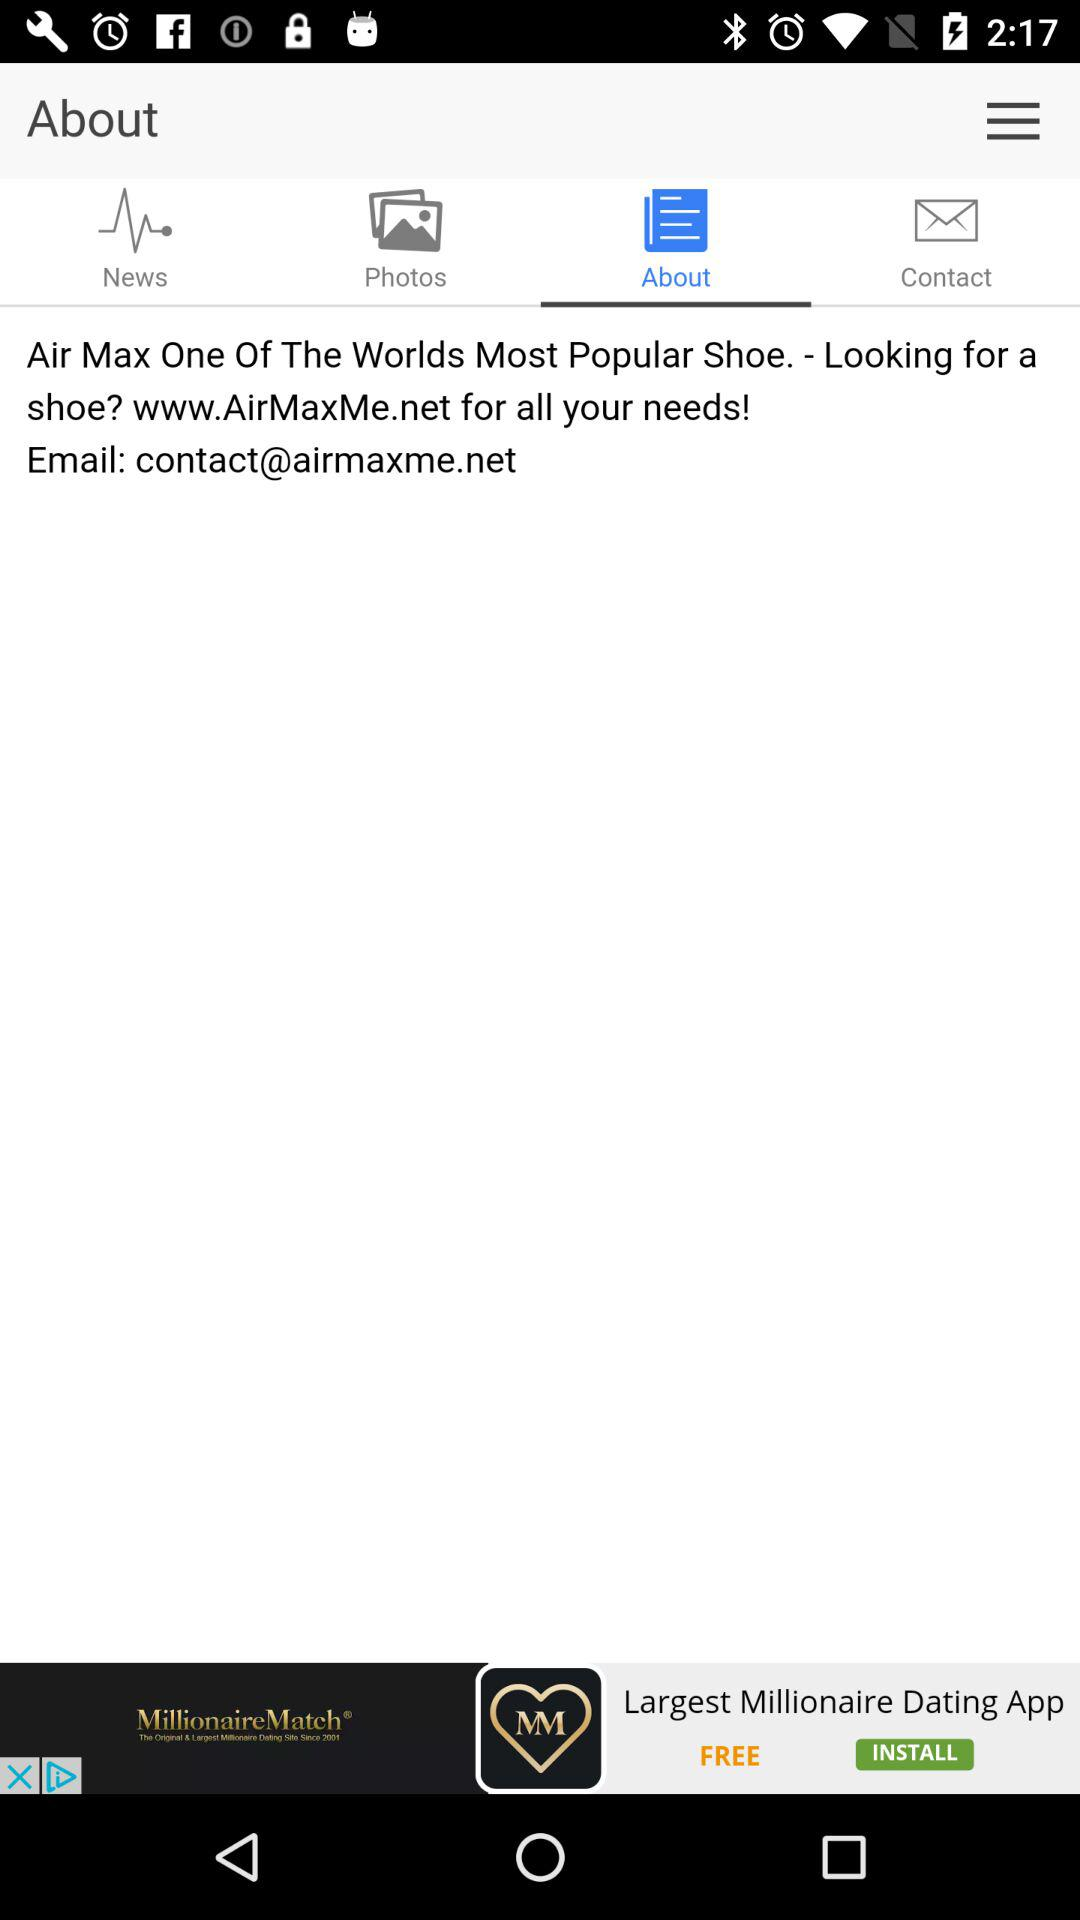Which tab is selected? The selected tab is "About". 